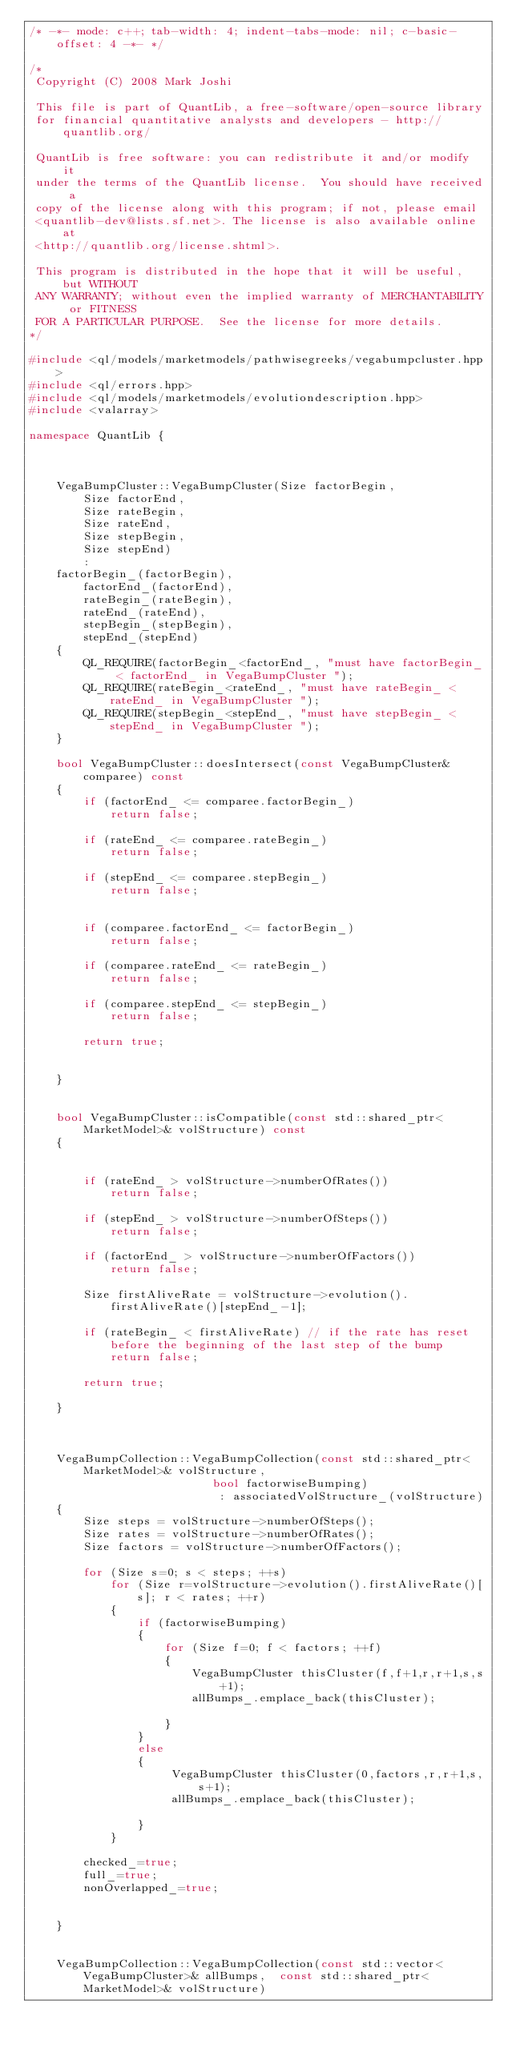<code> <loc_0><loc_0><loc_500><loc_500><_C++_>/* -*- mode: c++; tab-width: 4; indent-tabs-mode: nil; c-basic-offset: 4 -*- */

/*
 Copyright (C) 2008 Mark Joshi

 This file is part of QuantLib, a free-software/open-source library
 for financial quantitative analysts and developers - http://quantlib.org/

 QuantLib is free software: you can redistribute it and/or modify it
 under the terms of the QuantLib license.  You should have received a
 copy of the license along with this program; if not, please email
 <quantlib-dev@lists.sf.net>. The license is also available online at
 <http://quantlib.org/license.shtml>.

 This program is distributed in the hope that it will be useful, but WITHOUT
 ANY WARRANTY; without even the implied warranty of MERCHANTABILITY or FITNESS
 FOR A PARTICULAR PURPOSE.  See the license for more details.
*/

#include <ql/models/marketmodels/pathwisegreeks/vegabumpcluster.hpp>
#include <ql/errors.hpp>
#include <ql/models/marketmodels/evolutiondescription.hpp>
#include <valarray>

namespace QuantLib {



    VegaBumpCluster::VegaBumpCluster(Size factorBegin,
        Size factorEnd,
        Size rateBegin,
        Size rateEnd,
        Size stepBegin,
        Size stepEnd)
        :
    factorBegin_(factorBegin),
        factorEnd_(factorEnd),
        rateBegin_(rateBegin),
        rateEnd_(rateEnd),
        stepBegin_(stepBegin),
        stepEnd_(stepEnd)
    {
        QL_REQUIRE(factorBegin_<factorEnd_, "must have factorBegin_ < factorEnd_ in VegaBumpCluster ");
        QL_REQUIRE(rateBegin_<rateEnd_, "must have rateBegin_ < rateEnd_ in VegaBumpCluster ");
        QL_REQUIRE(stepBegin_<stepEnd_, "must have stepBegin_ < stepEnd_ in VegaBumpCluster ");
    }

    bool VegaBumpCluster::doesIntersect(const VegaBumpCluster& comparee) const
    {
        if (factorEnd_ <= comparee.factorBegin_)
            return false;

        if (rateEnd_ <= comparee.rateBegin_)
            return false;

        if (stepEnd_ <= comparee.stepBegin_)
            return false;


        if (comparee.factorEnd_ <= factorBegin_)
            return false;

        if (comparee.rateEnd_ <= rateBegin_)
            return false;

        if (comparee.stepEnd_ <= stepBegin_)
            return false;

        return true;


    }


    bool VegaBumpCluster::isCompatible(const std::shared_ptr<MarketModel>& volStructure) const
    {


        if (rateEnd_ > volStructure->numberOfRates())
            return false;

        if (stepEnd_ > volStructure->numberOfSteps())
            return false;

        if (factorEnd_ > volStructure->numberOfFactors())
            return false;

        Size firstAliveRate = volStructure->evolution().firstAliveRate()[stepEnd_-1];

        if (rateBegin_ < firstAliveRate) // if the rate has reset before the beginning of the last step of the bump
            return false;

        return true;

    }



    VegaBumpCollection::VegaBumpCollection(const std::shared_ptr<MarketModel>& volStructure,
                           bool factorwiseBumping)
                            : associatedVolStructure_(volStructure)
    {
        Size steps = volStructure->numberOfSteps();
        Size rates = volStructure->numberOfRates();
        Size factors = volStructure->numberOfFactors();

        for (Size s=0; s < steps; ++s)
            for (Size r=volStructure->evolution().firstAliveRate()[s]; r < rates; ++r)
            {
                if (factorwiseBumping)
                {
                    for (Size f=0; f < factors; ++f)
                    {
                        VegaBumpCluster thisCluster(f,f+1,r,r+1,s,s+1);
                        allBumps_.emplace_back(thisCluster);

                    }
                }
                else
                {
                     VegaBumpCluster thisCluster(0,factors,r,r+1,s,s+1);
                     allBumps_.emplace_back(thisCluster);

                }
            }

        checked_=true;
        full_=true;
        nonOverlapped_=true;


    }


    VegaBumpCollection::VegaBumpCollection(const std::vector<VegaBumpCluster>& allBumps,  const std::shared_ptr<MarketModel>& volStructure)</code> 